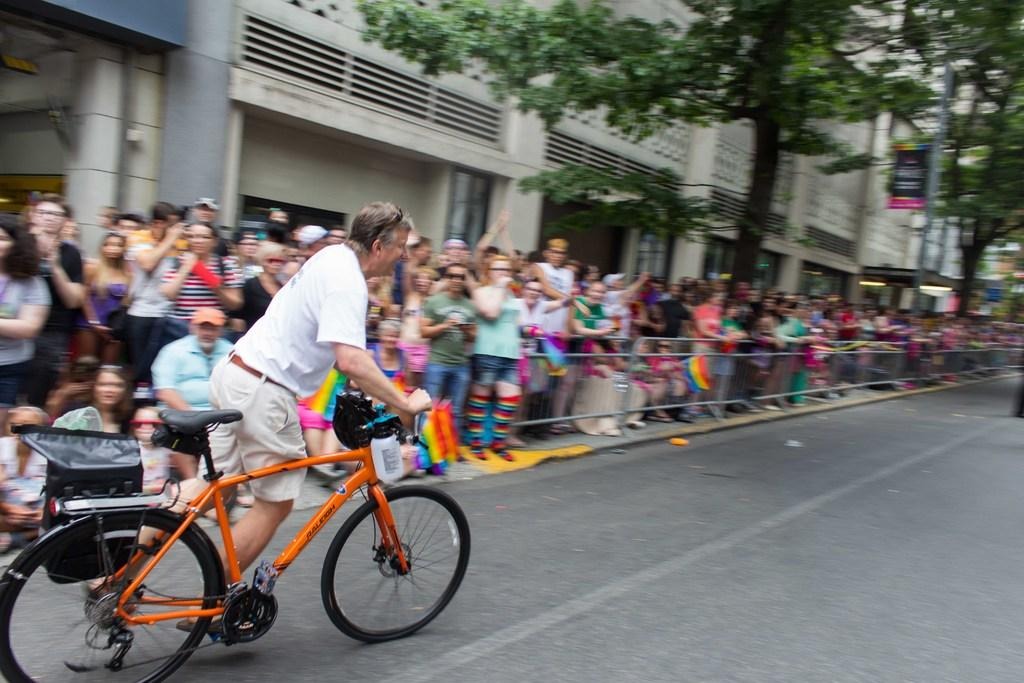What is the main subject of the image? There is a person riding a bicycle in the image. Are there any other people in the image? Yes, there is a group of people standing to the left of the cyclist. What can be seen in the background of the image? There is a tree, a board, and a building in the background of the image. What type of brain can be seen in the image? There is no brain present in the image. How does the cyclist say good-bye to the group of people in the image? The image does not show the cyclist saying good-bye to the group of people, as it only captures a moment in time. 